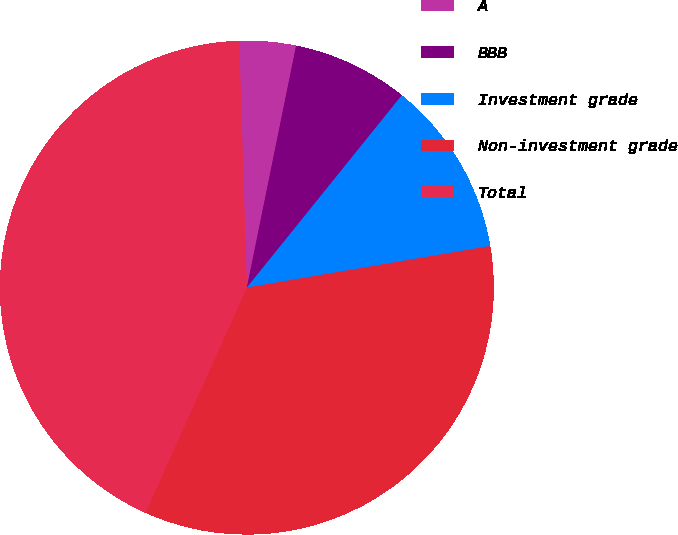<chart> <loc_0><loc_0><loc_500><loc_500><pie_chart><fcel>A<fcel>BBB<fcel>Investment grade<fcel>Non-investment grade<fcel>Total<nl><fcel>3.69%<fcel>7.6%<fcel>11.51%<fcel>34.43%<fcel>42.77%<nl></chart> 